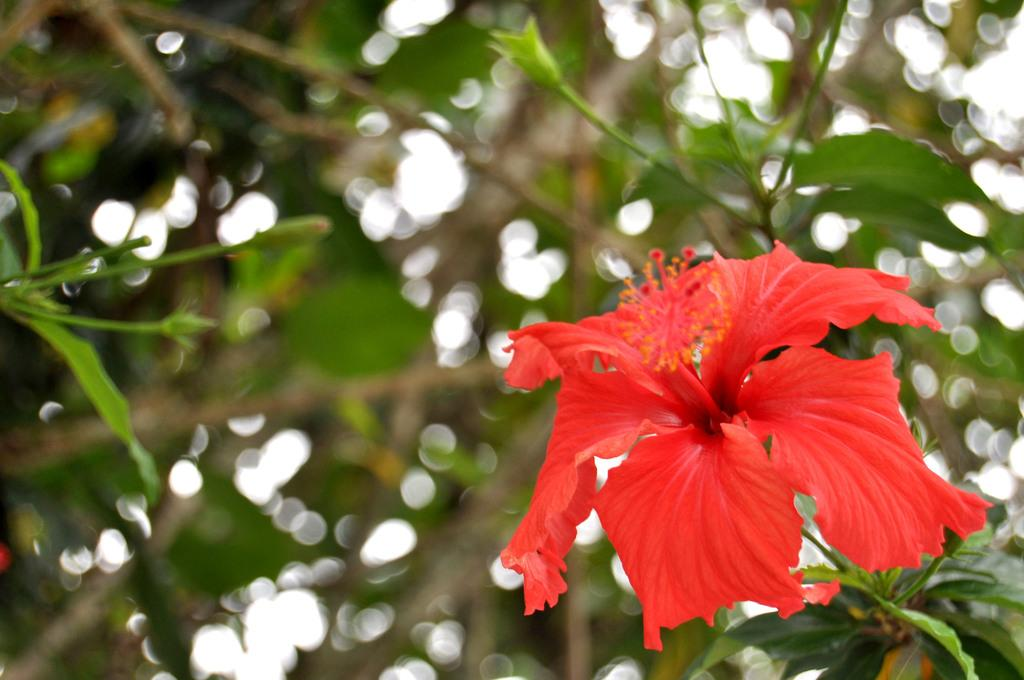What is the main subject of the image? There is a flower in the image. What other plant elements can be seen in the image? There are leaves in the image. Can you describe the background of the image? The background of the image is blurred. Where is the toothbrush located in the image? There is no toothbrush present in the image. What type of flame can be seen in the image? There is no flame present in the image. 